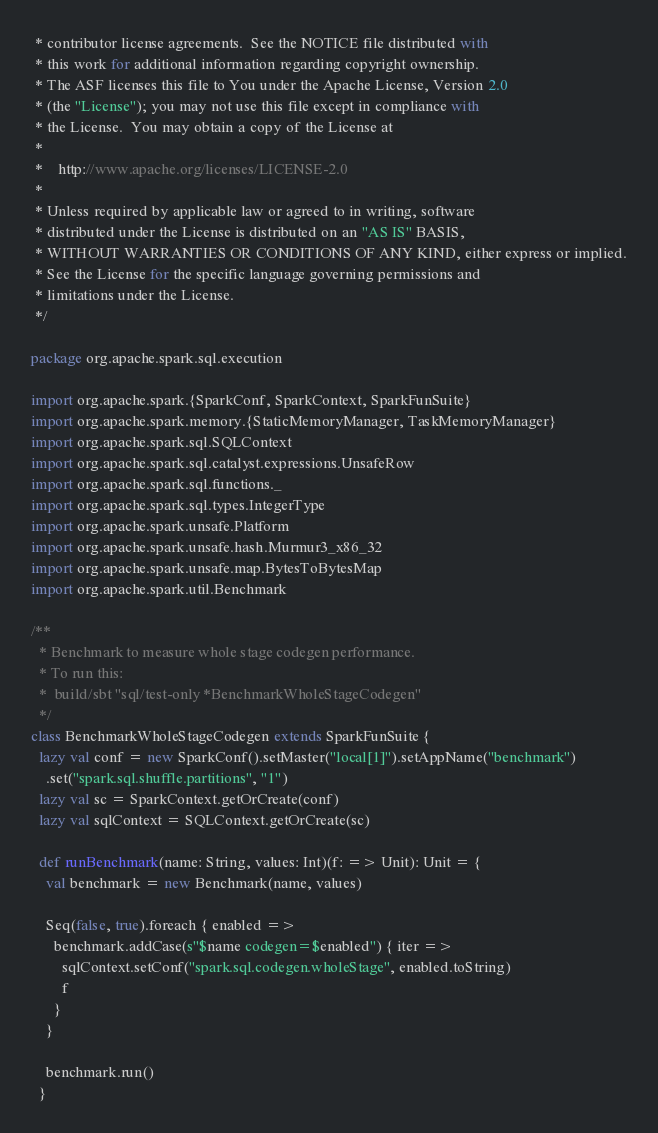Convert code to text. <code><loc_0><loc_0><loc_500><loc_500><_Scala_> * contributor license agreements.  See the NOTICE file distributed with
 * this work for additional information regarding copyright ownership.
 * The ASF licenses this file to You under the Apache License, Version 2.0
 * (the "License"); you may not use this file except in compliance with
 * the License.  You may obtain a copy of the License at
 *
 *    http://www.apache.org/licenses/LICENSE-2.0
 *
 * Unless required by applicable law or agreed to in writing, software
 * distributed under the License is distributed on an "AS IS" BASIS,
 * WITHOUT WARRANTIES OR CONDITIONS OF ANY KIND, either express or implied.
 * See the License for the specific language governing permissions and
 * limitations under the License.
 */

package org.apache.spark.sql.execution

import org.apache.spark.{SparkConf, SparkContext, SparkFunSuite}
import org.apache.spark.memory.{StaticMemoryManager, TaskMemoryManager}
import org.apache.spark.sql.SQLContext
import org.apache.spark.sql.catalyst.expressions.UnsafeRow
import org.apache.spark.sql.functions._
import org.apache.spark.sql.types.IntegerType
import org.apache.spark.unsafe.Platform
import org.apache.spark.unsafe.hash.Murmur3_x86_32
import org.apache.spark.unsafe.map.BytesToBytesMap
import org.apache.spark.util.Benchmark

/**
  * Benchmark to measure whole stage codegen performance.
  * To run this:
  *  build/sbt "sql/test-only *BenchmarkWholeStageCodegen"
  */
class BenchmarkWholeStageCodegen extends SparkFunSuite {
  lazy val conf = new SparkConf().setMaster("local[1]").setAppName("benchmark")
    .set("spark.sql.shuffle.partitions", "1")
  lazy val sc = SparkContext.getOrCreate(conf)
  lazy val sqlContext = SQLContext.getOrCreate(sc)

  def runBenchmark(name: String, values: Int)(f: => Unit): Unit = {
    val benchmark = new Benchmark(name, values)

    Seq(false, true).foreach { enabled =>
      benchmark.addCase(s"$name codegen=$enabled") { iter =>
        sqlContext.setConf("spark.sql.codegen.wholeStage", enabled.toString)
        f
      }
    }

    benchmark.run()
  }
</code> 